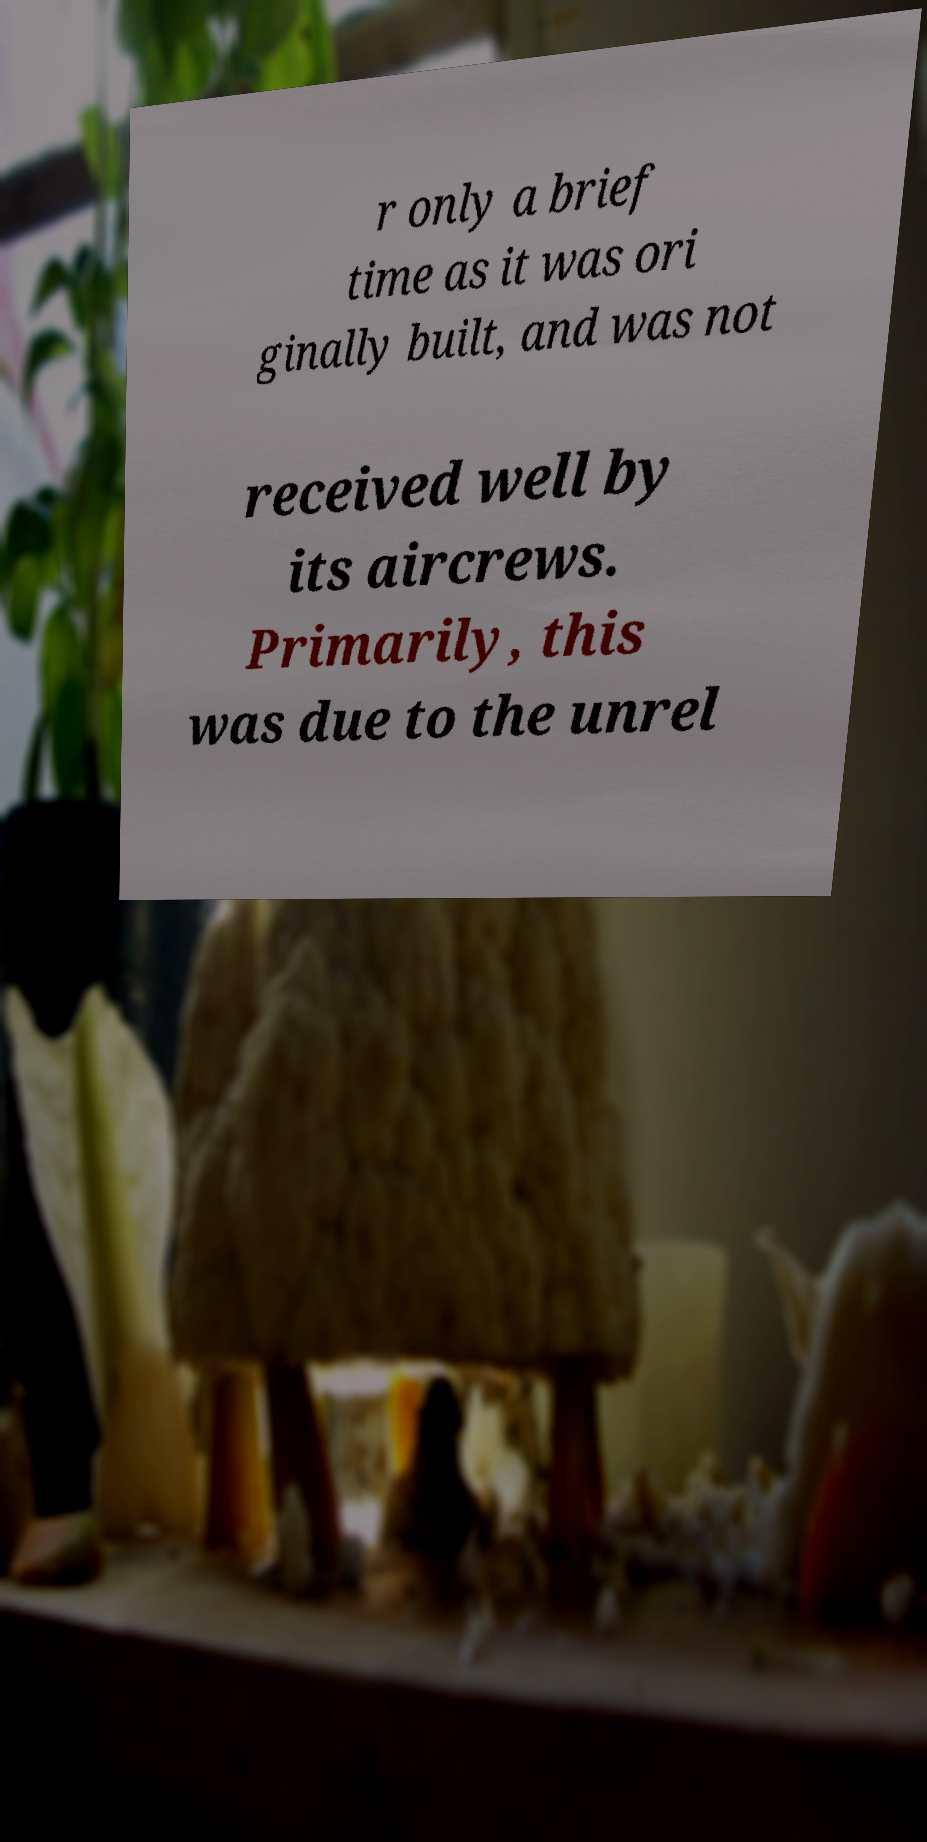Please identify and transcribe the text found in this image. r only a brief time as it was ori ginally built, and was not received well by its aircrews. Primarily, this was due to the unrel 